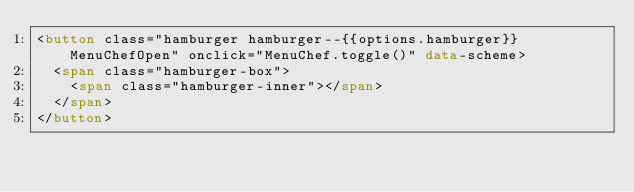Convert code to text. <code><loc_0><loc_0><loc_500><loc_500><_HTML_><button class="hamburger hamburger--{{options.hamburger}} MenuChefOpen" onclick="MenuChef.toggle()" data-scheme>
  <span class="hamburger-box">
    <span class="hamburger-inner"></span>
  </span>
</button></code> 